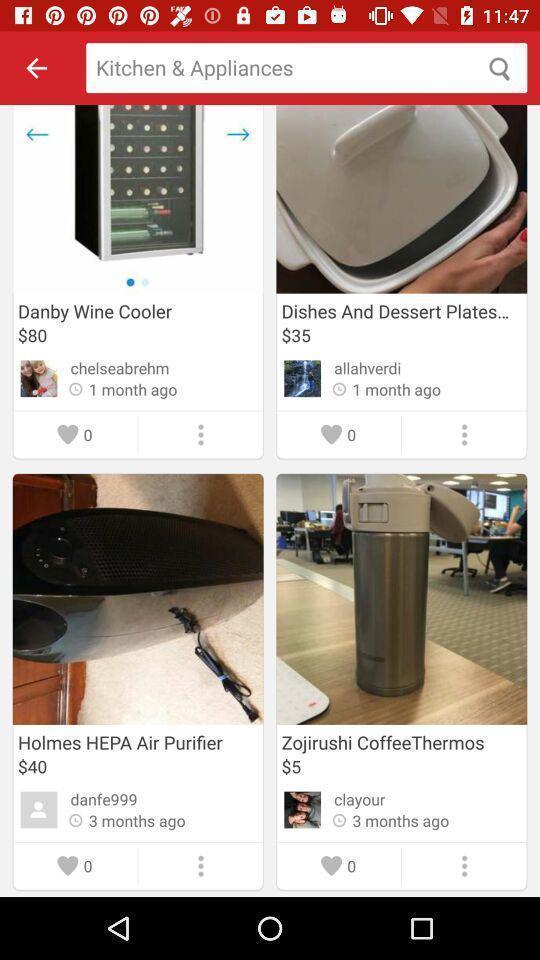Summarize the main components in this picture. Search page with list of items in the shopping app. 